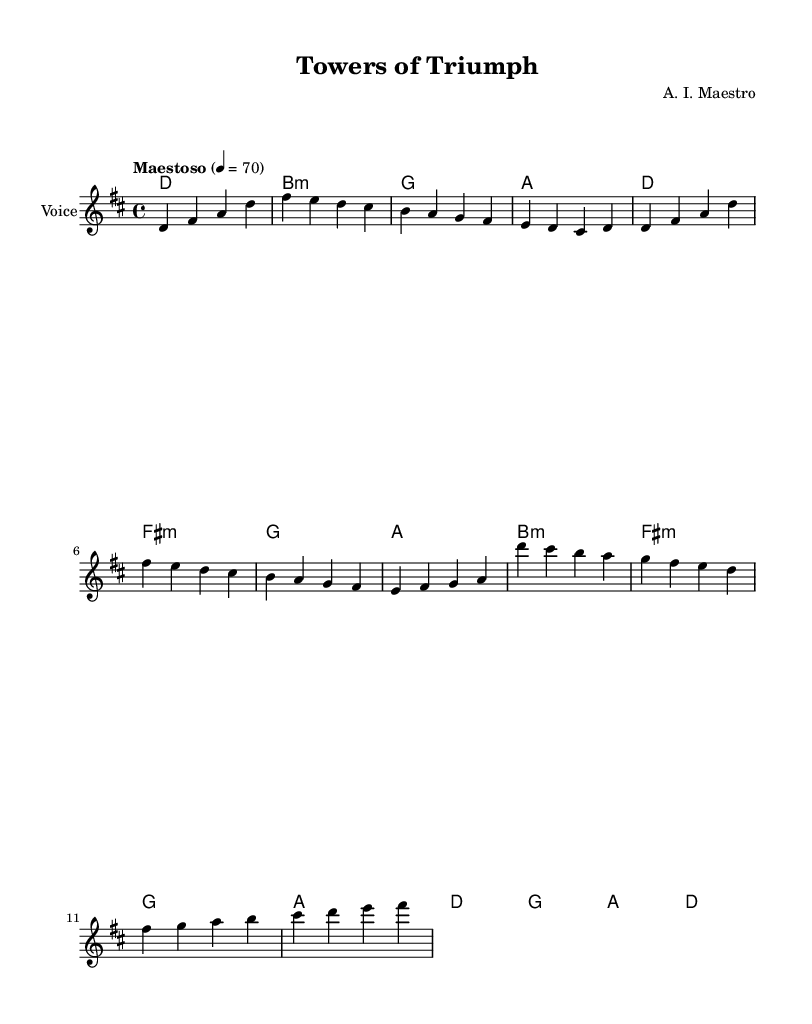What is the key signature of this music? The key signature is D major, which includes two sharps: F# and C#.
Answer: D major What is the time signature of this piece? The time signature is indicated at the beginning of the score and is 4/4, meaning there are four beats per measure.
Answer: 4/4 What tempo marking is given for this composition? The tempo marking is "Maestoso," indicating a majestic and stately pace, set to a quarter note equals 70 beats per minute.
Answer: Maestoso How many bars are in the introduction section? The introduction section consists of four measures as shown in the melody line provided.
Answer: 4 What does the term "verse" indicate in this sheet music? The term "verse" denotes a section that contains lyrics and is often used to convey the narrative or thematic content in opera, as seen in the score.
Answer: Section with lyrics What is the title of this operatic work? The title appears at the top of the sheet music in the header section, denoting it as "Towers of Triumph."
Answer: Towers of Triumph How many times is the chorus repeated in this melody? The chorus appears once in the melody and is usually structured as an easily recognizable thematic refrain within operatic compositions.
Answer: Once 